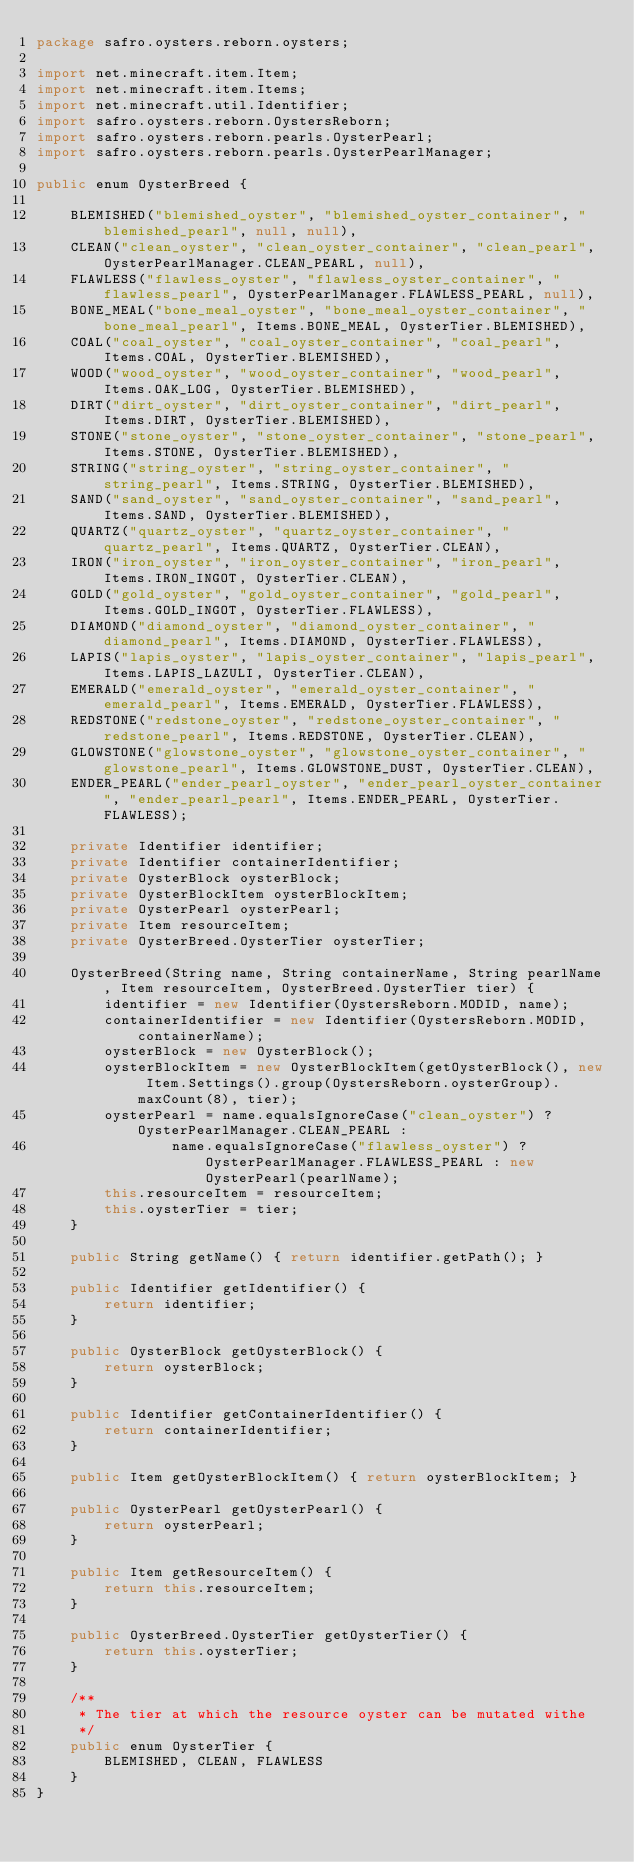<code> <loc_0><loc_0><loc_500><loc_500><_Java_>package safro.oysters.reborn.oysters;

import net.minecraft.item.Item;
import net.minecraft.item.Items;
import net.minecraft.util.Identifier;
import safro.oysters.reborn.OystersReborn;
import safro.oysters.reborn.pearls.OysterPearl;
import safro.oysters.reborn.pearls.OysterPearlManager;

public enum OysterBreed {

    BLEMISHED("blemished_oyster", "blemished_oyster_container", "blemished_pearl", null, null),
    CLEAN("clean_oyster", "clean_oyster_container", "clean_pearl", OysterPearlManager.CLEAN_PEARL, null),
    FLAWLESS("flawless_oyster", "flawless_oyster_container", "flawless_pearl", OysterPearlManager.FLAWLESS_PEARL, null),
    BONE_MEAL("bone_meal_oyster", "bone_meal_oyster_container", "bone_meal_pearl", Items.BONE_MEAL, OysterTier.BLEMISHED),
    COAL("coal_oyster", "coal_oyster_container", "coal_pearl", Items.COAL, OysterTier.BLEMISHED),
    WOOD("wood_oyster", "wood_oyster_container", "wood_pearl", Items.OAK_LOG, OysterTier.BLEMISHED),
    DIRT("dirt_oyster", "dirt_oyster_container", "dirt_pearl", Items.DIRT, OysterTier.BLEMISHED),
    STONE("stone_oyster", "stone_oyster_container", "stone_pearl", Items.STONE, OysterTier.BLEMISHED),
    STRING("string_oyster", "string_oyster_container", "string_pearl", Items.STRING, OysterTier.BLEMISHED),
    SAND("sand_oyster", "sand_oyster_container", "sand_pearl", Items.SAND, OysterTier.BLEMISHED),
    QUARTZ("quartz_oyster", "quartz_oyster_container", "quartz_pearl", Items.QUARTZ, OysterTier.CLEAN),
    IRON("iron_oyster", "iron_oyster_container", "iron_pearl", Items.IRON_INGOT, OysterTier.CLEAN),
    GOLD("gold_oyster", "gold_oyster_container", "gold_pearl", Items.GOLD_INGOT, OysterTier.FLAWLESS),
    DIAMOND("diamond_oyster", "diamond_oyster_container", "diamond_pearl", Items.DIAMOND, OysterTier.FLAWLESS),
    LAPIS("lapis_oyster", "lapis_oyster_container", "lapis_pearl", Items.LAPIS_LAZULI, OysterTier.CLEAN),
    EMERALD("emerald_oyster", "emerald_oyster_container", "emerald_pearl", Items.EMERALD, OysterTier.FLAWLESS),
    REDSTONE("redstone_oyster", "redstone_oyster_container", "redstone_pearl", Items.REDSTONE, OysterTier.CLEAN),
    GLOWSTONE("glowstone_oyster", "glowstone_oyster_container", "glowstone_pearl", Items.GLOWSTONE_DUST, OysterTier.CLEAN),
    ENDER_PEARL("ender_pearl_oyster", "ender_pearl_oyster_container", "ender_pearl_pearl", Items.ENDER_PEARL, OysterTier.FLAWLESS);

    private Identifier identifier;
    private Identifier containerIdentifier;
    private OysterBlock oysterBlock;
    private OysterBlockItem oysterBlockItem;
    private OysterPearl oysterPearl;
    private Item resourceItem;
    private OysterBreed.OysterTier oysterTier;

    OysterBreed(String name, String containerName, String pearlName, Item resourceItem, OysterBreed.OysterTier tier) {
        identifier = new Identifier(OystersReborn.MODID, name);
        containerIdentifier = new Identifier(OystersReborn.MODID, containerName);
        oysterBlock = new OysterBlock();
        oysterBlockItem = new OysterBlockItem(getOysterBlock(), new Item.Settings().group(OystersReborn.oysterGroup).maxCount(8), tier);
        oysterPearl = name.equalsIgnoreCase("clean_oyster") ? OysterPearlManager.CLEAN_PEARL :
                name.equalsIgnoreCase("flawless_oyster") ? OysterPearlManager.FLAWLESS_PEARL : new OysterPearl(pearlName);
        this.resourceItem = resourceItem;
        this.oysterTier = tier;
    }

    public String getName() { return identifier.getPath(); }

    public Identifier getIdentifier() {
        return identifier;
    }

    public OysterBlock getOysterBlock() {
        return oysterBlock;
    }

    public Identifier getContainerIdentifier() {
        return containerIdentifier;
    }

    public Item getOysterBlockItem() { return oysterBlockItem; }

    public OysterPearl getOysterPearl() {
        return oysterPearl;
    }

    public Item getResourceItem() {
        return this.resourceItem;
    }

    public OysterBreed.OysterTier getOysterTier() {
        return this.oysterTier;
    }

    /**
     * The tier at which the resource oyster can be mutated withe
     */
    public enum OysterTier {
        BLEMISHED, CLEAN, FLAWLESS
    }
}
</code> 